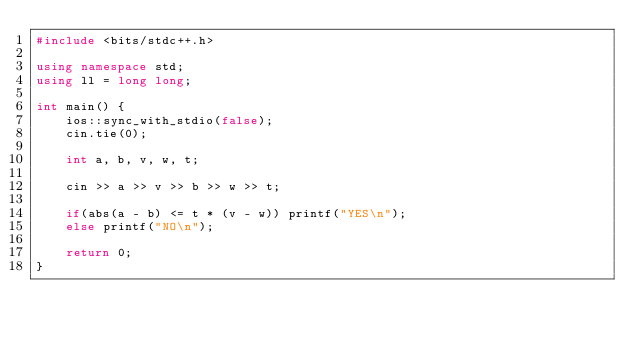Convert code to text. <code><loc_0><loc_0><loc_500><loc_500><_C++_>#include <bits/stdc++.h>

using namespace std;
using ll = long long;

int main() {
    ios::sync_with_stdio(false);
    cin.tie(0);

    int a, b, v, w, t;

    cin >> a >> v >> b >> w >> t;

    if(abs(a - b) <= t * (v - w)) printf("YES\n");
    else printf("NO\n");

    return 0;
}</code> 